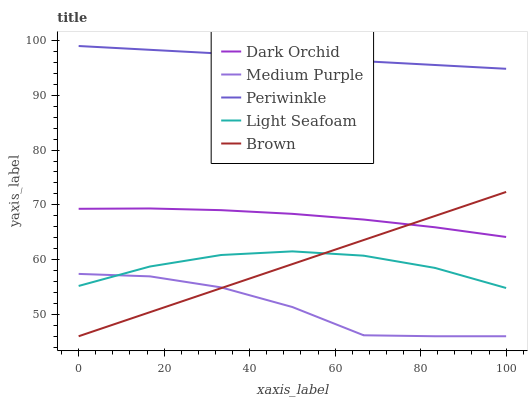Does Medium Purple have the minimum area under the curve?
Answer yes or no. Yes. Does Periwinkle have the maximum area under the curve?
Answer yes or no. Yes. Does Brown have the minimum area under the curve?
Answer yes or no. No. Does Brown have the maximum area under the curve?
Answer yes or no. No. Is Periwinkle the smoothest?
Answer yes or no. Yes. Is Medium Purple the roughest?
Answer yes or no. Yes. Is Brown the smoothest?
Answer yes or no. No. Is Brown the roughest?
Answer yes or no. No. Does Light Seafoam have the lowest value?
Answer yes or no. No. Does Periwinkle have the highest value?
Answer yes or no. Yes. Does Brown have the highest value?
Answer yes or no. No. Is Light Seafoam less than Periwinkle?
Answer yes or no. Yes. Is Periwinkle greater than Dark Orchid?
Answer yes or no. Yes. Does Medium Purple intersect Brown?
Answer yes or no. Yes. Is Medium Purple less than Brown?
Answer yes or no. No. Is Medium Purple greater than Brown?
Answer yes or no. No. Does Light Seafoam intersect Periwinkle?
Answer yes or no. No. 